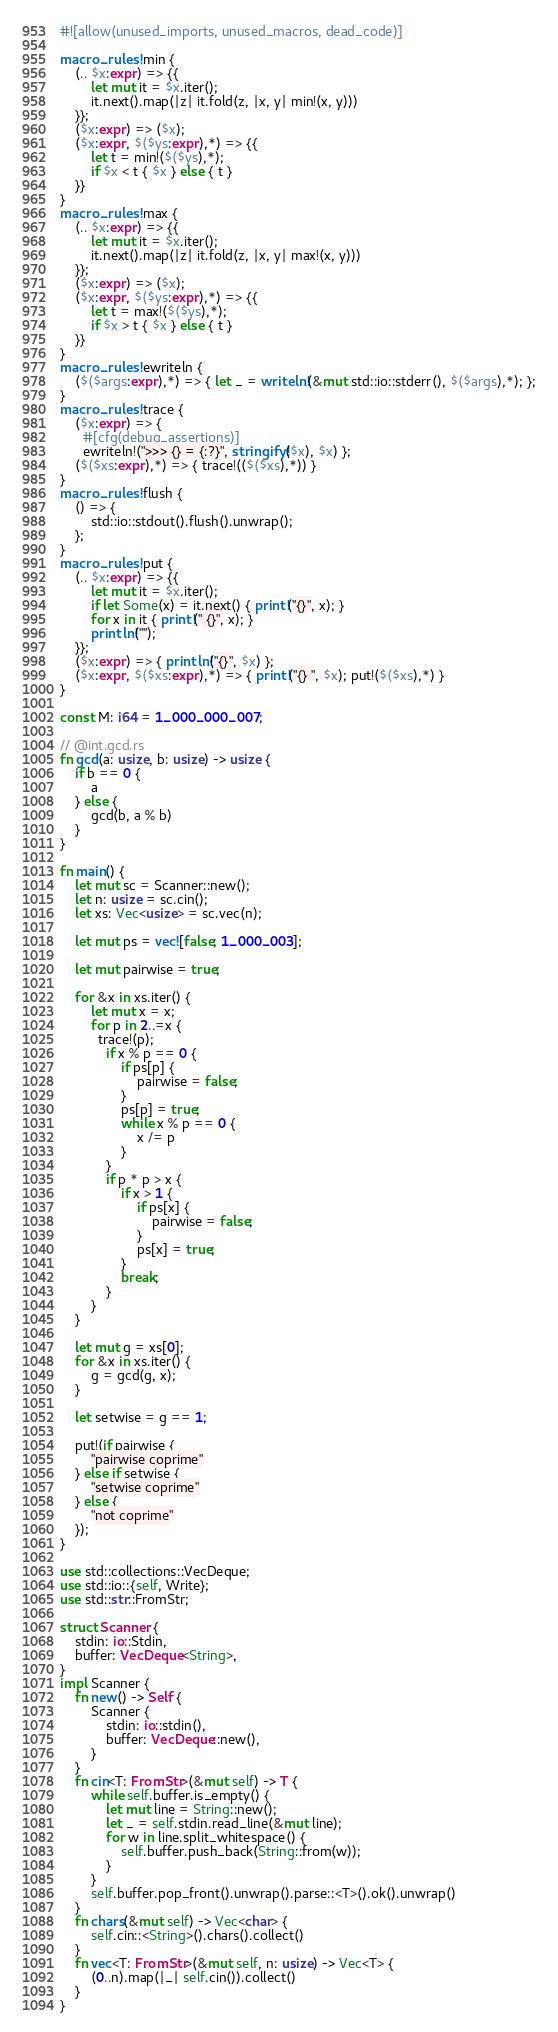Convert code to text. <code><loc_0><loc_0><loc_500><loc_500><_Rust_>#![allow(unused_imports, unused_macros, dead_code)]

macro_rules! min {
    (.. $x:expr) => {{
        let mut it = $x.iter();
        it.next().map(|z| it.fold(z, |x, y| min!(x, y)))
    }};
    ($x:expr) => ($x);
    ($x:expr, $($ys:expr),*) => {{
        let t = min!($($ys),*);
        if $x < t { $x } else { t }
    }}
}
macro_rules! max {
    (.. $x:expr) => {{
        let mut it = $x.iter();
        it.next().map(|z| it.fold(z, |x, y| max!(x, y)))
    }};
    ($x:expr) => ($x);
    ($x:expr, $($ys:expr),*) => {{
        let t = max!($($ys),*);
        if $x > t { $x } else { t }
    }}
}
macro_rules! ewriteln {
    ($($args:expr),*) => { let _ = writeln!(&mut std::io::stderr(), $($args),*); };
}
macro_rules! trace {
    ($x:expr) => {
      #[cfg(debug_assertions)]
      ewriteln!(">>> {} = {:?}", stringify!($x), $x) };
    ($($xs:expr),*) => { trace!(($($xs),*)) }
}
macro_rules! flush {
    () => {
        std::io::stdout().flush().unwrap();
    };
}
macro_rules! put {
    (.. $x:expr) => {{
        let mut it = $x.iter();
        if let Some(x) = it.next() { print!("{}", x); }
        for x in it { print!(" {}", x); }
        println!("");
    }};
    ($x:expr) => { println!("{}", $x) };
    ($x:expr, $($xs:expr),*) => { print!("{} ", $x); put!($($xs),*) }
}

const M: i64 = 1_000_000_007;

// @int.gcd.rs
fn gcd(a: usize, b: usize) -> usize {
    if b == 0 {
        a
    } else {
        gcd(b, a % b)
    }
}

fn main() {
    let mut sc = Scanner::new();
    let n: usize = sc.cin();
    let xs: Vec<usize> = sc.vec(n);

    let mut ps = vec![false; 1_000_003];

    let mut pairwise = true;

    for &x in xs.iter() {
        let mut x = x;
        for p in 2..=x {
          trace!(p);
            if x % p == 0 {
                if ps[p] {
                    pairwise = false;
                }
                ps[p] = true;
                while x % p == 0 {
                    x /= p
                }
            }
            if p * p > x {
                if x > 1 {
                    if ps[x] {
                        pairwise = false;
                    }
                    ps[x] = true;
                }
                break;
            }
        }
    }

    let mut g = xs[0];
    for &x in xs.iter() {
        g = gcd(g, x);
    }

    let setwise = g == 1;

    put!(if pairwise {
        "pairwise coprime"
    } else if setwise {
        "setwise coprime"
    } else {
        "not coprime"
    });
}

use std::collections::VecDeque;
use std::io::{self, Write};
use std::str::FromStr;

struct Scanner {
    stdin: io::Stdin,
    buffer: VecDeque<String>,
}
impl Scanner {
    fn new() -> Self {
        Scanner {
            stdin: io::stdin(),
            buffer: VecDeque::new(),
        }
    }
    fn cin<T: FromStr>(&mut self) -> T {
        while self.buffer.is_empty() {
            let mut line = String::new();
            let _ = self.stdin.read_line(&mut line);
            for w in line.split_whitespace() {
                self.buffer.push_back(String::from(w));
            }
        }
        self.buffer.pop_front().unwrap().parse::<T>().ok().unwrap()
    }
    fn chars(&mut self) -> Vec<char> {
        self.cin::<String>().chars().collect()
    }
    fn vec<T: FromStr>(&mut self, n: usize) -> Vec<T> {
        (0..n).map(|_| self.cin()).collect()
    }
}
</code> 